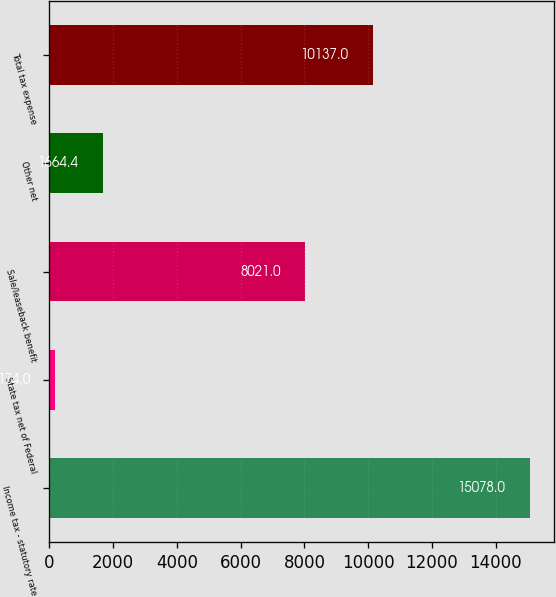Convert chart. <chart><loc_0><loc_0><loc_500><loc_500><bar_chart><fcel>Income tax - statutory rate<fcel>State tax net of Federal<fcel>Sale/leaseback benefit<fcel>Other net<fcel>Total tax expense<nl><fcel>15078<fcel>174<fcel>8021<fcel>1664.4<fcel>10137<nl></chart> 